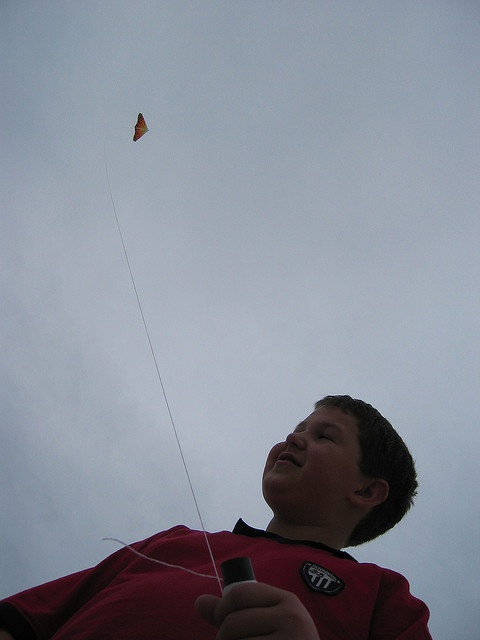Describe the objects in this image and their specific colors. I can see people in gray, black, maroon, and darkgray tones and kite in gray, maroon, olive, and black tones in this image. 